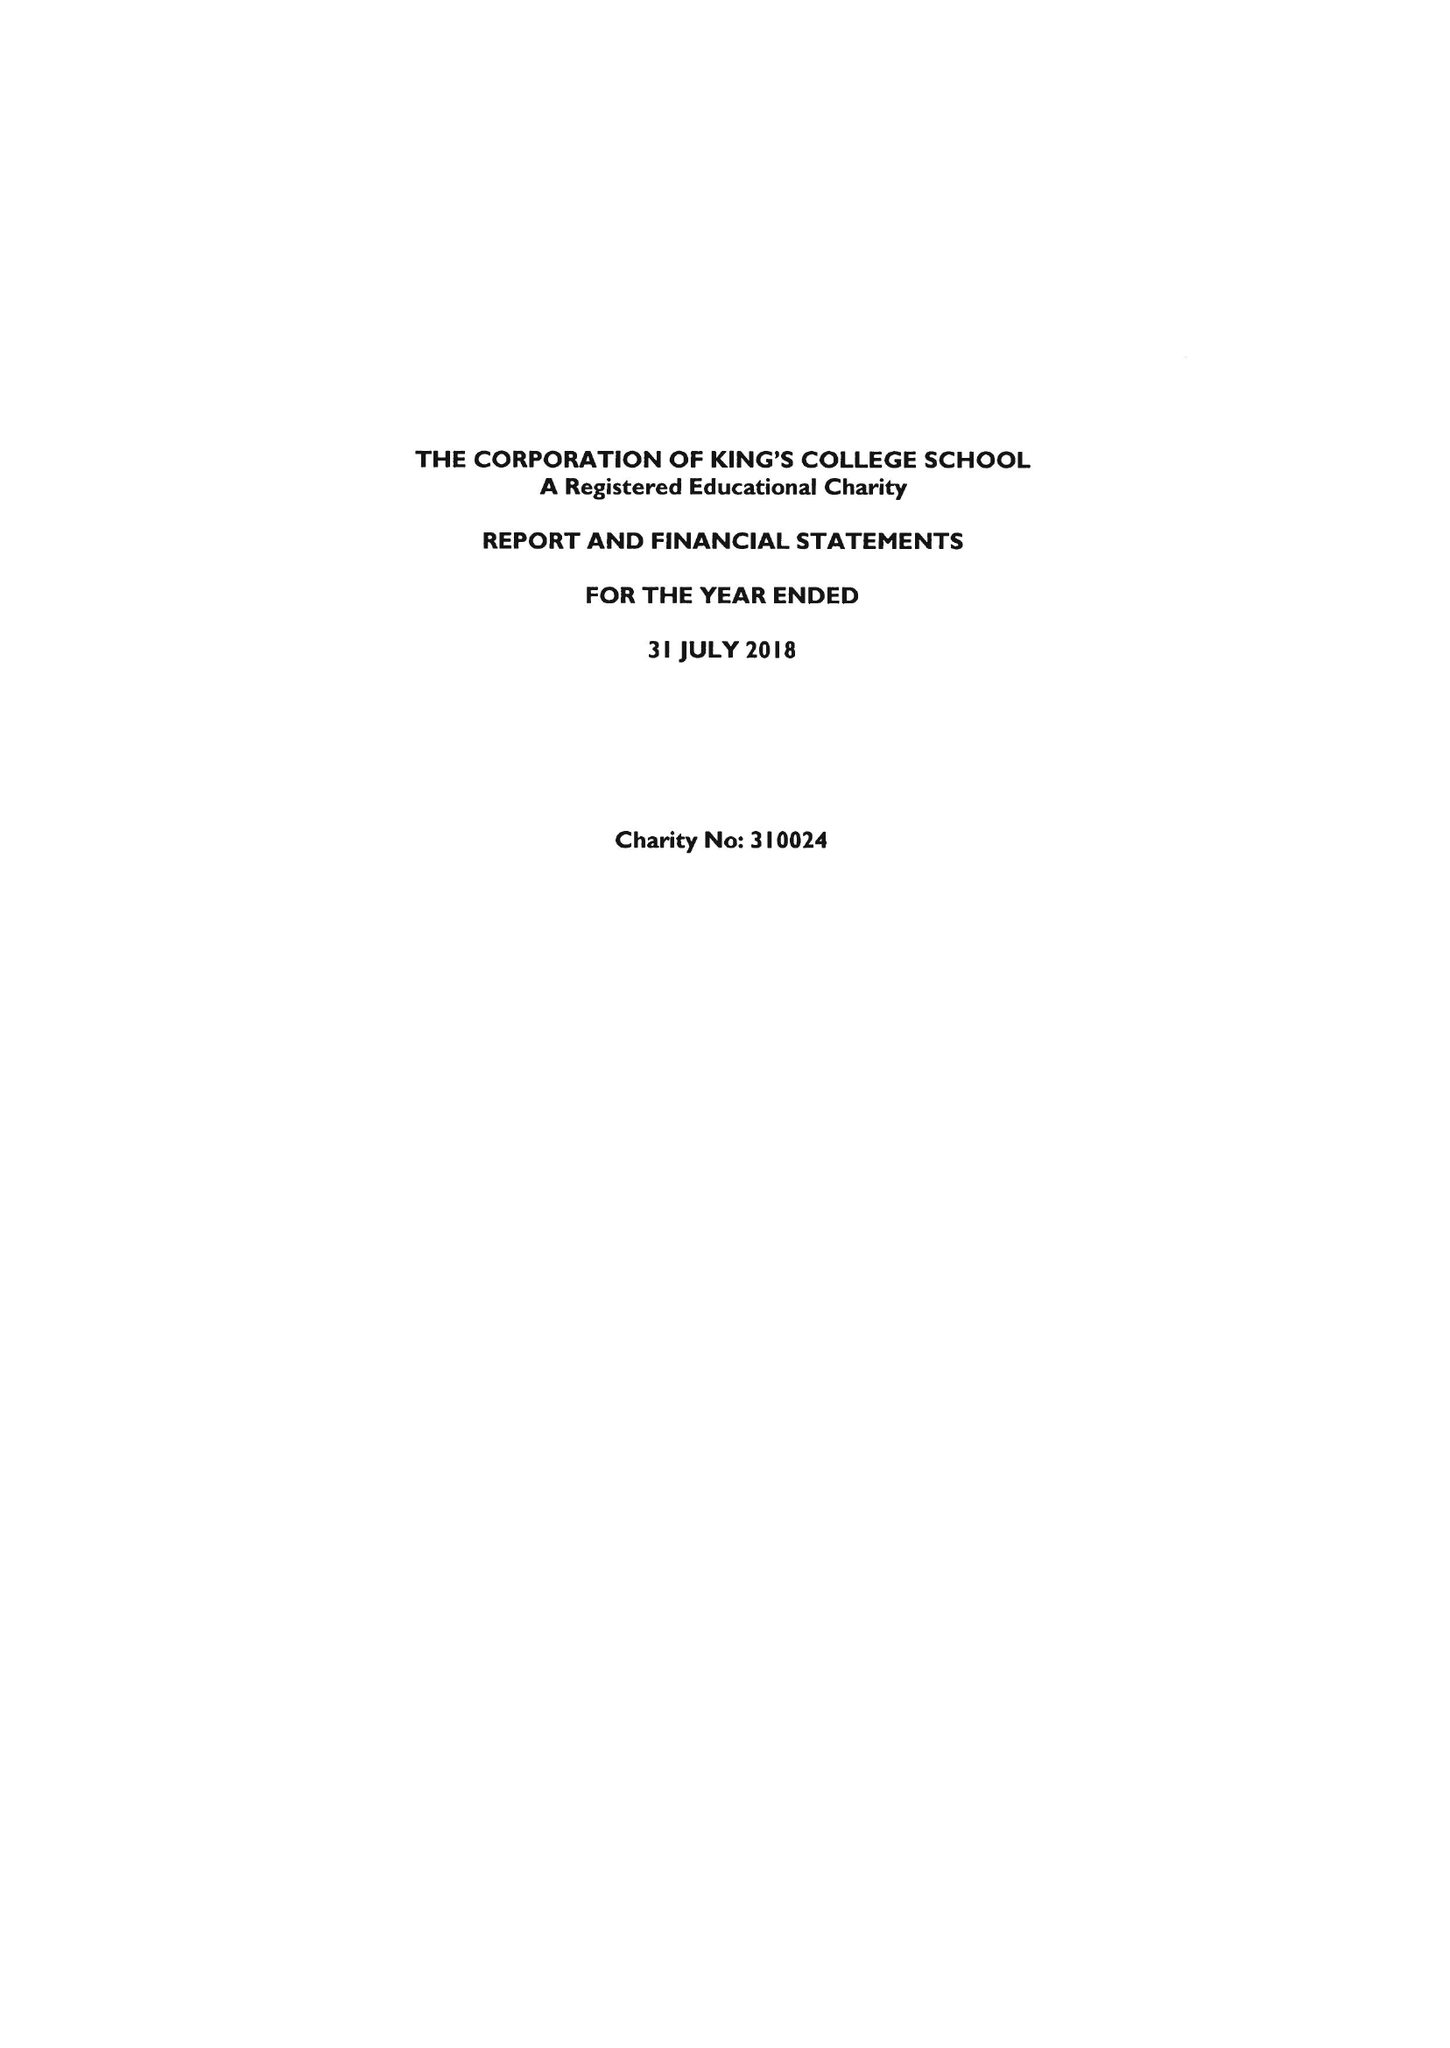What is the value for the charity_name?
Answer the question using a single word or phrase. King's College School 